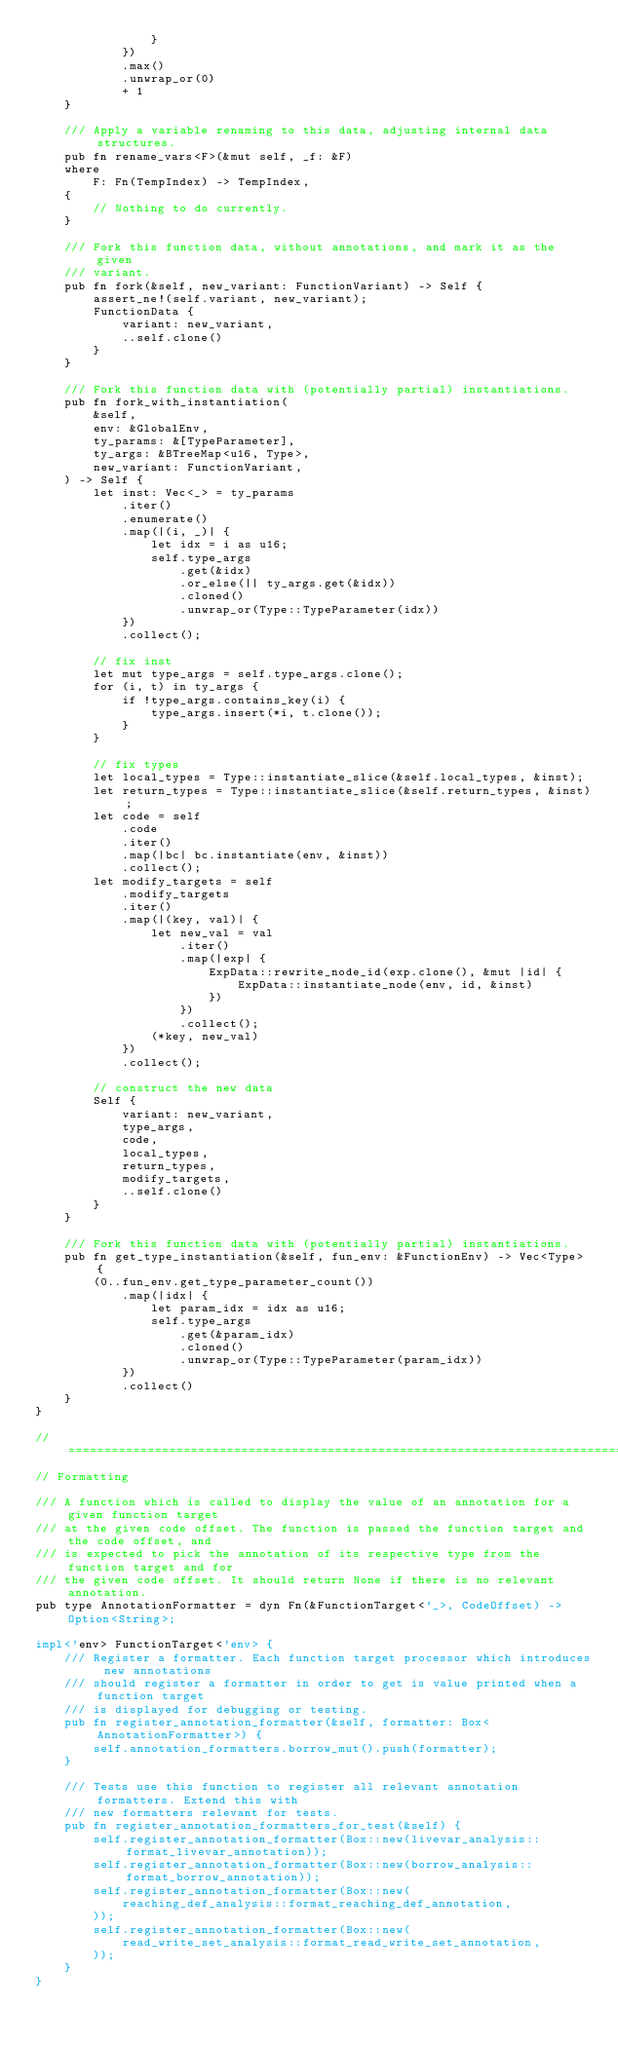<code> <loc_0><loc_0><loc_500><loc_500><_Rust_>                }
            })
            .max()
            .unwrap_or(0)
            + 1
    }

    /// Apply a variable renaming to this data, adjusting internal data structures.
    pub fn rename_vars<F>(&mut self, _f: &F)
    where
        F: Fn(TempIndex) -> TempIndex,
    {
        // Nothing to do currently.
    }

    /// Fork this function data, without annotations, and mark it as the given
    /// variant.
    pub fn fork(&self, new_variant: FunctionVariant) -> Self {
        assert_ne!(self.variant, new_variant);
        FunctionData {
            variant: new_variant,
            ..self.clone()
        }
    }

    /// Fork this function data with (potentially partial) instantiations.
    pub fn fork_with_instantiation(
        &self,
        env: &GlobalEnv,
        ty_params: &[TypeParameter],
        ty_args: &BTreeMap<u16, Type>,
        new_variant: FunctionVariant,
    ) -> Self {
        let inst: Vec<_> = ty_params
            .iter()
            .enumerate()
            .map(|(i, _)| {
                let idx = i as u16;
                self.type_args
                    .get(&idx)
                    .or_else(|| ty_args.get(&idx))
                    .cloned()
                    .unwrap_or(Type::TypeParameter(idx))
            })
            .collect();

        // fix inst
        let mut type_args = self.type_args.clone();
        for (i, t) in ty_args {
            if !type_args.contains_key(i) {
                type_args.insert(*i, t.clone());
            }
        }

        // fix types
        let local_types = Type::instantiate_slice(&self.local_types, &inst);
        let return_types = Type::instantiate_slice(&self.return_types, &inst);
        let code = self
            .code
            .iter()
            .map(|bc| bc.instantiate(env, &inst))
            .collect();
        let modify_targets = self
            .modify_targets
            .iter()
            .map(|(key, val)| {
                let new_val = val
                    .iter()
                    .map(|exp| {
                        ExpData::rewrite_node_id(exp.clone(), &mut |id| {
                            ExpData::instantiate_node(env, id, &inst)
                        })
                    })
                    .collect();
                (*key, new_val)
            })
            .collect();

        // construct the new data
        Self {
            variant: new_variant,
            type_args,
            code,
            local_types,
            return_types,
            modify_targets,
            ..self.clone()
        }
    }

    /// Fork this function data with (potentially partial) instantiations.
    pub fn get_type_instantiation(&self, fun_env: &FunctionEnv) -> Vec<Type> {
        (0..fun_env.get_type_parameter_count())
            .map(|idx| {
                let param_idx = idx as u16;
                self.type_args
                    .get(&param_idx)
                    .cloned()
                    .unwrap_or(Type::TypeParameter(param_idx))
            })
            .collect()
    }
}

// =================================================================================================
// Formatting

/// A function which is called to display the value of an annotation for a given function target
/// at the given code offset. The function is passed the function target and the code offset, and
/// is expected to pick the annotation of its respective type from the function target and for
/// the given code offset. It should return None if there is no relevant annotation.
pub type AnnotationFormatter = dyn Fn(&FunctionTarget<'_>, CodeOffset) -> Option<String>;

impl<'env> FunctionTarget<'env> {
    /// Register a formatter. Each function target processor which introduces new annotations
    /// should register a formatter in order to get is value printed when a function target
    /// is displayed for debugging or testing.
    pub fn register_annotation_formatter(&self, formatter: Box<AnnotationFormatter>) {
        self.annotation_formatters.borrow_mut().push(formatter);
    }

    /// Tests use this function to register all relevant annotation formatters. Extend this with
    /// new formatters relevant for tests.
    pub fn register_annotation_formatters_for_test(&self) {
        self.register_annotation_formatter(Box::new(livevar_analysis::format_livevar_annotation));
        self.register_annotation_formatter(Box::new(borrow_analysis::format_borrow_annotation));
        self.register_annotation_formatter(Box::new(
            reaching_def_analysis::format_reaching_def_annotation,
        ));
        self.register_annotation_formatter(Box::new(
            read_write_set_analysis::format_read_write_set_annotation,
        ));
    }
}
</code> 